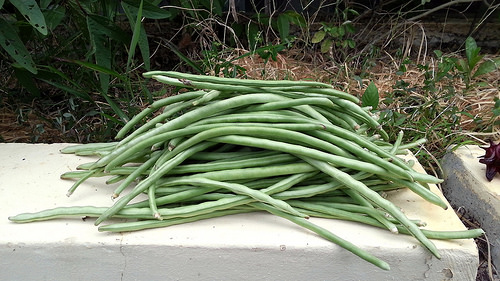<image>
Is there a beans to the right of the plant? Yes. From this viewpoint, the beans is positioned to the right side relative to the plant. 